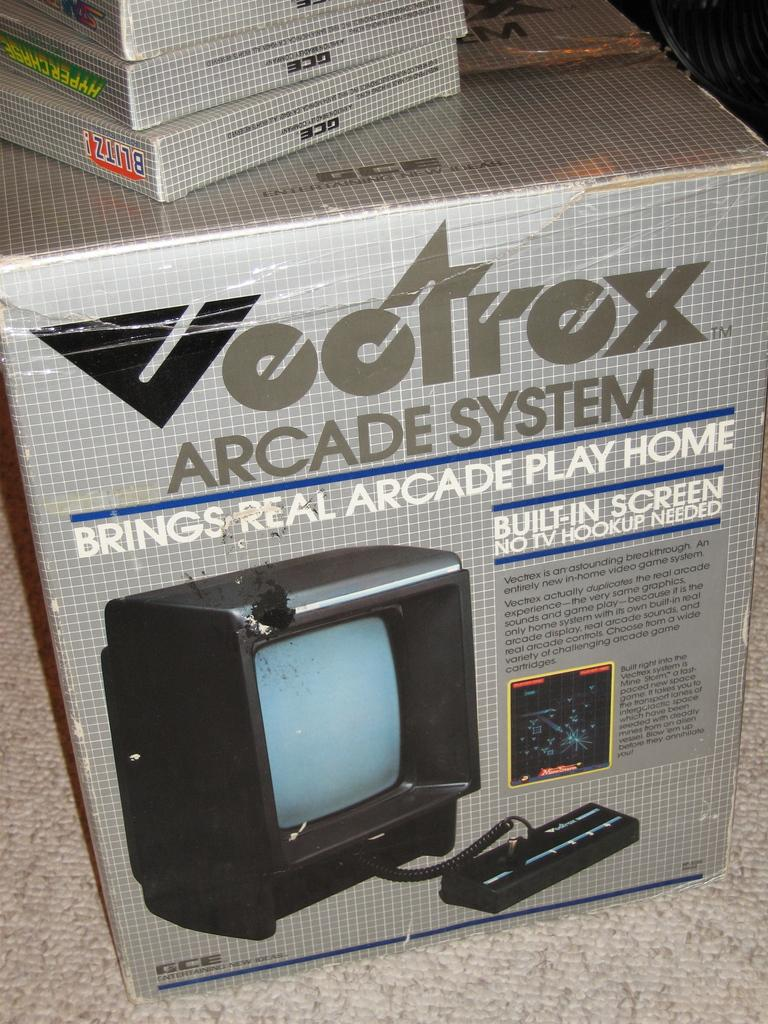What is the main object in the image? There is a box in the image. Where is the box located? The box is placed on a surface. How many boxes are stacked on top of the first box? There are three boxes on top of the first box. What time of day is it in the image, and what type of butter is being used? The time of day and type of butter are not mentioned or visible in the image. 